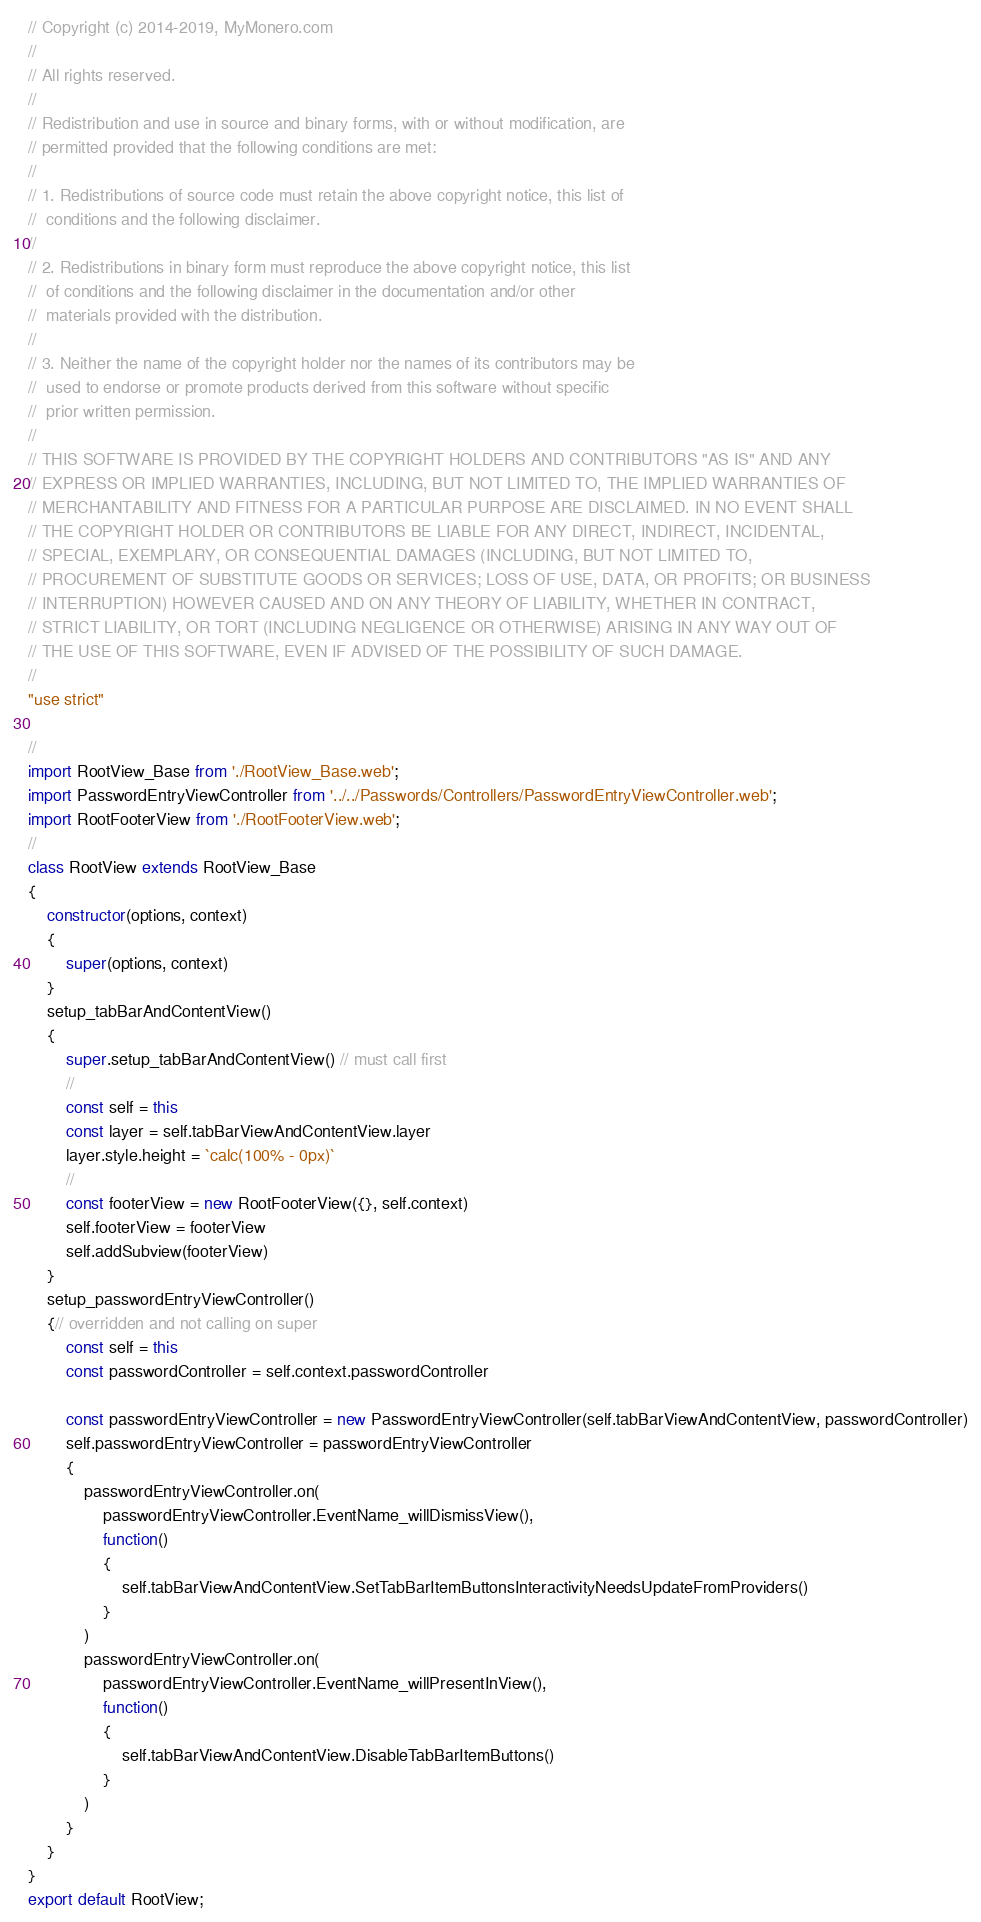Convert code to text. <code><loc_0><loc_0><loc_500><loc_500><_JavaScript_>// Copyright (c) 2014-2019, MyMonero.com
//
// All rights reserved.
//
// Redistribution and use in source and binary forms, with or without modification, are
// permitted provided that the following conditions are met:
//
// 1. Redistributions of source code must retain the above copyright notice, this list of
//	conditions and the following disclaimer.
//
// 2. Redistributions in binary form must reproduce the above copyright notice, this list
//	of conditions and the following disclaimer in the documentation and/or other
//	materials provided with the distribution.
//
// 3. Neither the name of the copyright holder nor the names of its contributors may be
//	used to endorse or promote products derived from this software without specific
//	prior written permission.
//
// THIS SOFTWARE IS PROVIDED BY THE COPYRIGHT HOLDERS AND CONTRIBUTORS "AS IS" AND ANY
// EXPRESS OR IMPLIED WARRANTIES, INCLUDING, BUT NOT LIMITED TO, THE IMPLIED WARRANTIES OF
// MERCHANTABILITY AND FITNESS FOR A PARTICULAR PURPOSE ARE DISCLAIMED. IN NO EVENT SHALL
// THE COPYRIGHT HOLDER OR CONTRIBUTORS BE LIABLE FOR ANY DIRECT, INDIRECT, INCIDENTAL,
// SPECIAL, EXEMPLARY, OR CONSEQUENTIAL DAMAGES (INCLUDING, BUT NOT LIMITED TO,
// PROCUREMENT OF SUBSTITUTE GOODS OR SERVICES; LOSS OF USE, DATA, OR PROFITS; OR BUSINESS
// INTERRUPTION) HOWEVER CAUSED AND ON ANY THEORY OF LIABILITY, WHETHER IN CONTRACT,
// STRICT LIABILITY, OR TORT (INCLUDING NEGLIGENCE OR OTHERWISE) ARISING IN ANY WAY OUT OF
// THE USE OF THIS SOFTWARE, EVEN IF ADVISED OF THE POSSIBILITY OF SUCH DAMAGE.
//
"use strict"

//
import RootView_Base from './RootView_Base.web';
import PasswordEntryViewController from '../../Passwords/Controllers/PasswordEntryViewController.web';
import RootFooterView from './RootFooterView.web';
//
class RootView extends RootView_Base
{
	constructor(options, context)
	{
		super(options, context)
	}
	setup_tabBarAndContentView()
	{
		super.setup_tabBarAndContentView() // must call first
		//
		const self = this
		const layer = self.tabBarViewAndContentView.layer
		layer.style.height = `calc(100% - 0px)`
		//
		const footerView = new RootFooterView({}, self.context)
		self.footerView = footerView
		self.addSubview(footerView)
	}
	setup_passwordEntryViewController()
	{// overridden and not calling on super
		const self = this
		const passwordController = self.context.passwordController
		
		const passwordEntryViewController = new PasswordEntryViewController(self.tabBarViewAndContentView, passwordController)
		self.passwordEntryViewController = passwordEntryViewController
		{
			passwordEntryViewController.on(
				passwordEntryViewController.EventName_willDismissView(),
				function()
				{
					self.tabBarViewAndContentView.SetTabBarItemButtonsInteractivityNeedsUpdateFromProviders()
				}
			)
			passwordEntryViewController.on(
				passwordEntryViewController.EventName_willPresentInView(),
				function()
				{
					self.tabBarViewAndContentView.DisableTabBarItemButtons()
				}
			)
		}
	}
}
export default RootView;
</code> 